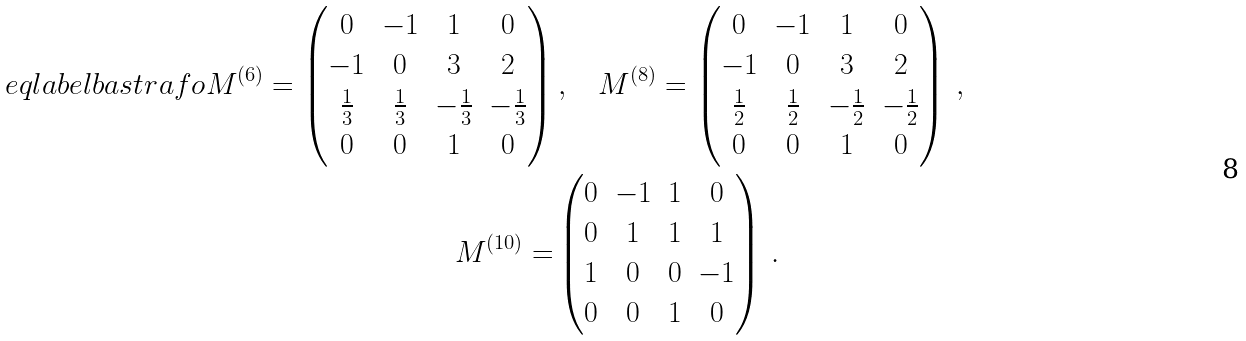Convert formula to latex. <formula><loc_0><loc_0><loc_500><loc_500>\ e q l a b e l { b a s t r a f o } M ^ { ( 6 ) } = \begin{pmatrix} 0 & - 1 & 1 & 0 \\ - 1 & 0 & 3 & 2 \\ \frac { 1 } { 3 } & \frac { 1 } { 3 } & - \frac { 1 } { 3 } & - \frac { 1 } { 3 } \\ 0 & 0 & 1 & 0 \end{pmatrix} & \, , \quad M ^ { ( 8 ) } = \begin{pmatrix} 0 & - 1 & 1 & 0 \\ - 1 & 0 & 3 & 2 \\ \frac { 1 } { 2 } & \frac { 1 } { 2 } & - \frac { 1 } { 2 } & - \frac { 1 } { 2 } \\ 0 & 0 & 1 & 0 \end{pmatrix} \, , \, \\ M ^ { ( 1 0 ) } = & \begin{pmatrix} 0 & - 1 & 1 & 0 \\ 0 & 1 & 1 & 1 \\ 1 & 0 & 0 & - 1 \\ 0 & 0 & 1 & 0 \end{pmatrix} \, .</formula> 